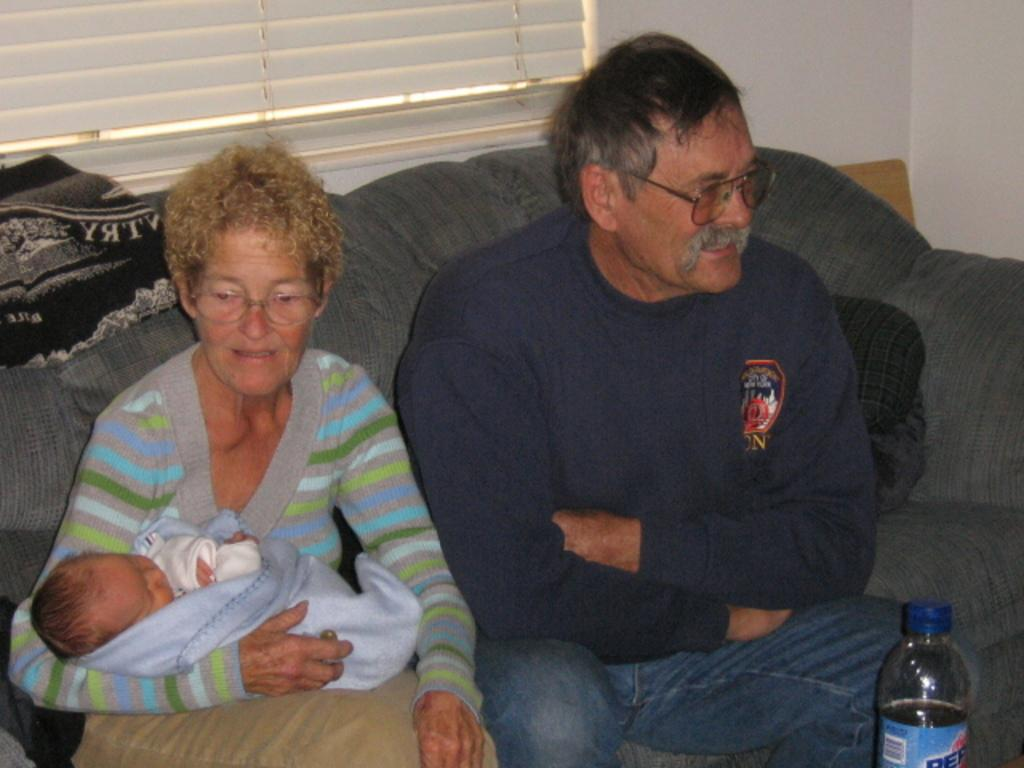What is the main setting of the image? There is a room in the image. What are the people in the room doing? People are sitting in the room. What piece of furniture is present in the room? There is a table in the room. What object can be seen on the table? There is a bottle on the table. What is the woman in the image doing? The woman is holding a baby. What accessory is the woman wearing? The woman is wearing spectacles. What time of day is it at the seashore in the image? There is no seashore present in the image; it is a room with people sitting and a table with a bottle. How many men are visible in the image? There is no information about men in the image; it only mentions people without specifying their gender. 